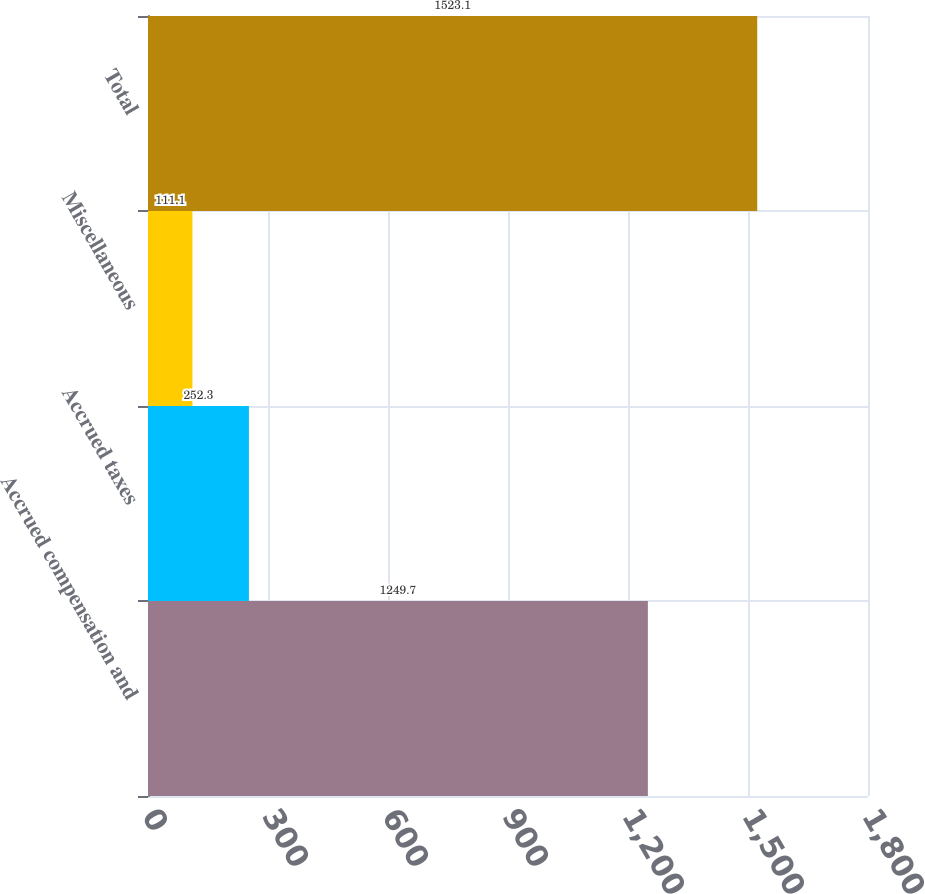Convert chart. <chart><loc_0><loc_0><loc_500><loc_500><bar_chart><fcel>Accrued compensation and<fcel>Accrued taxes<fcel>Miscellaneous<fcel>Total<nl><fcel>1249.7<fcel>252.3<fcel>111.1<fcel>1523.1<nl></chart> 